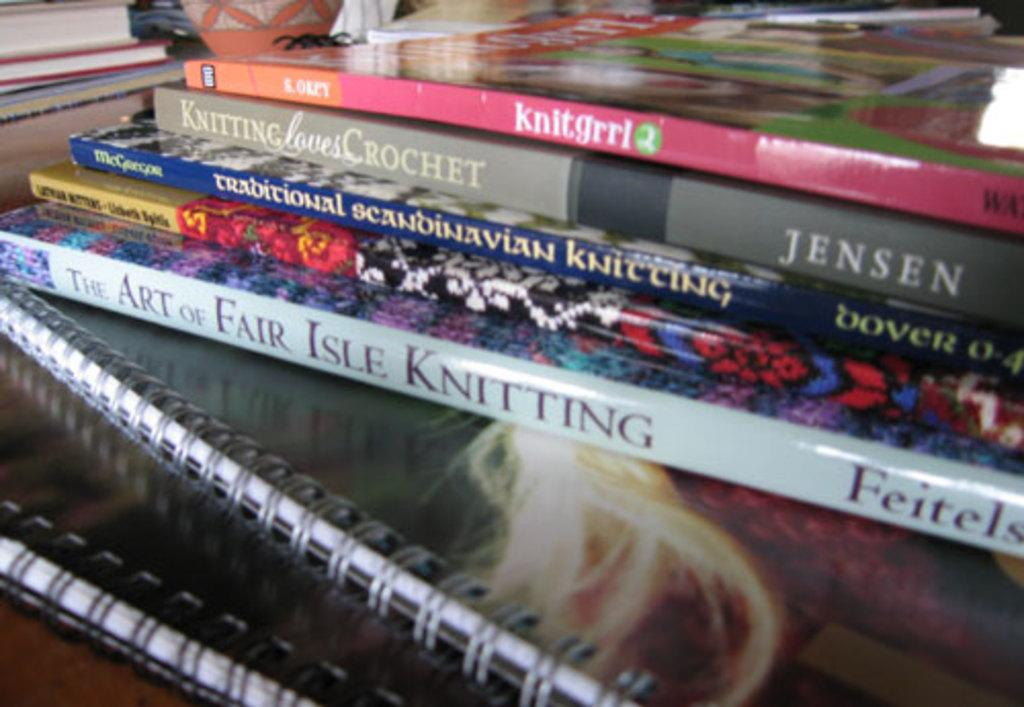<image>
Relay a brief, clear account of the picture shown. The Art of Fair Isle Knitting sits near the bottom of a stack of knitting books. 